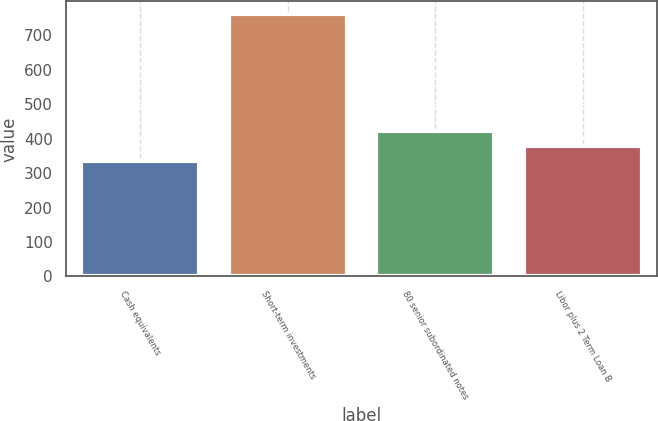Convert chart. <chart><loc_0><loc_0><loc_500><loc_500><bar_chart><fcel>Cash equivalents<fcel>Short-term investments<fcel>80 senior subordinated notes<fcel>Libor plus 2 Term Loan B<nl><fcel>336<fcel>761<fcel>421<fcel>378.5<nl></chart> 